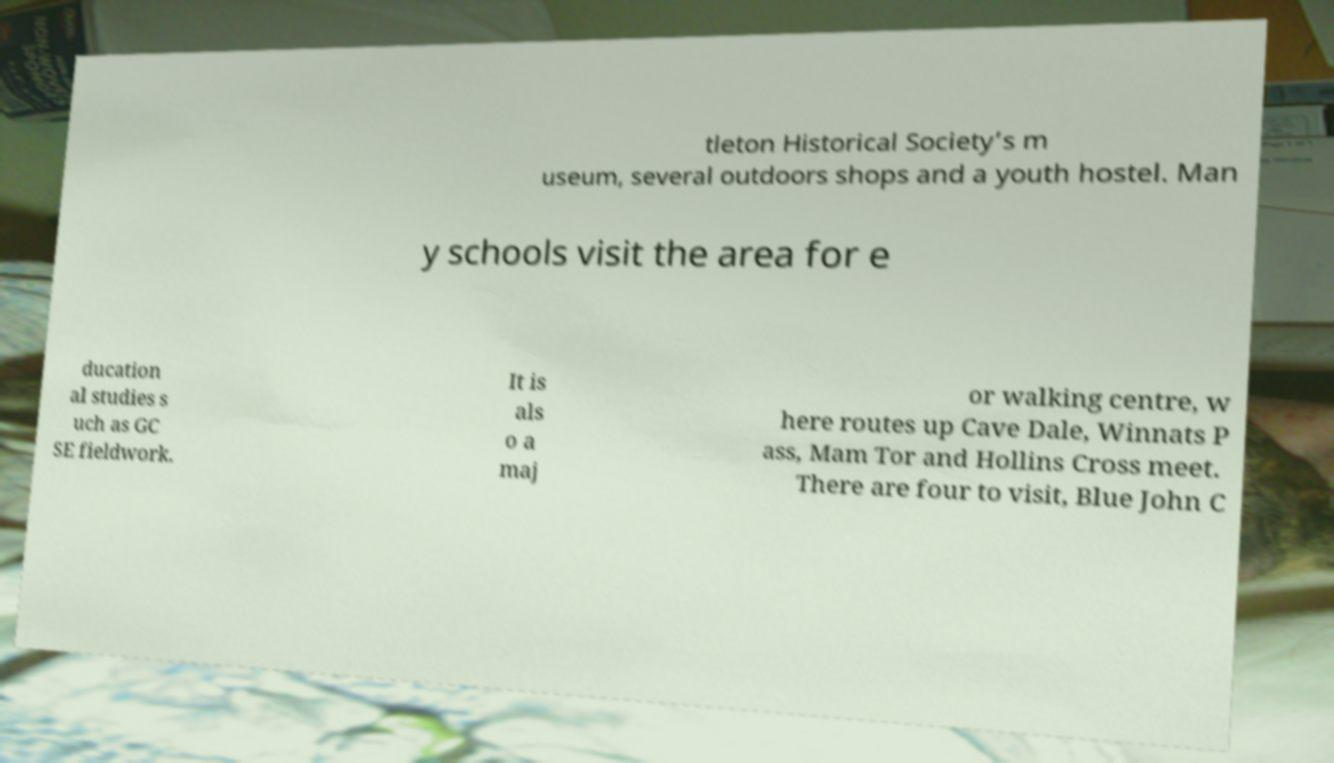Please read and relay the text visible in this image. What does it say? tleton Historical Society’s m useum, several outdoors shops and a youth hostel. Man y schools visit the area for e ducation al studies s uch as GC SE fieldwork. It is als o a maj or walking centre, w here routes up Cave Dale, Winnats P ass, Mam Tor and Hollins Cross meet. There are four to visit, Blue John C 